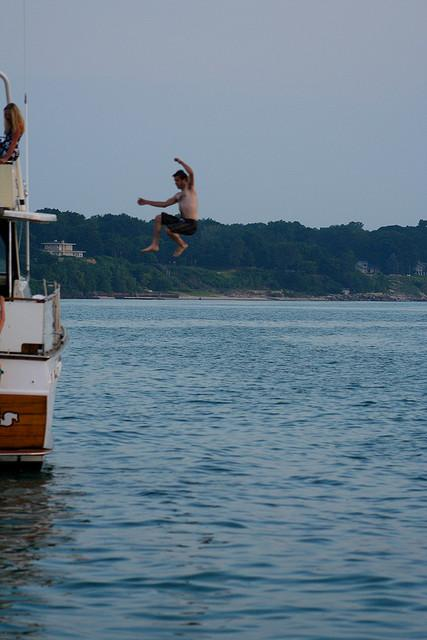Where does the man want to go? Please explain your reasoning. in water. He wants to go in the water. 